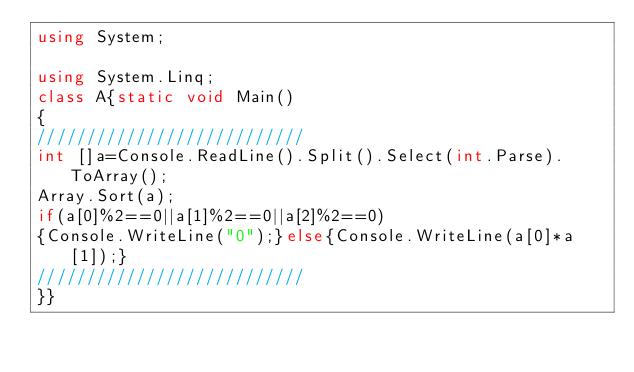<code> <loc_0><loc_0><loc_500><loc_500><_C#_>using System;

using System.Linq;
class A{static void Main()
{
///////////////////////////
int []a=Console.ReadLine().Split().Select(int.Parse).ToArray();
Array.Sort(a);
if(a[0]%2==0||a[1]%2==0||a[2]%2==0)
{Console.WriteLine("0");}else{Console.WriteLine(a[0]*a[1]);}
///////////////////////////
}}</code> 